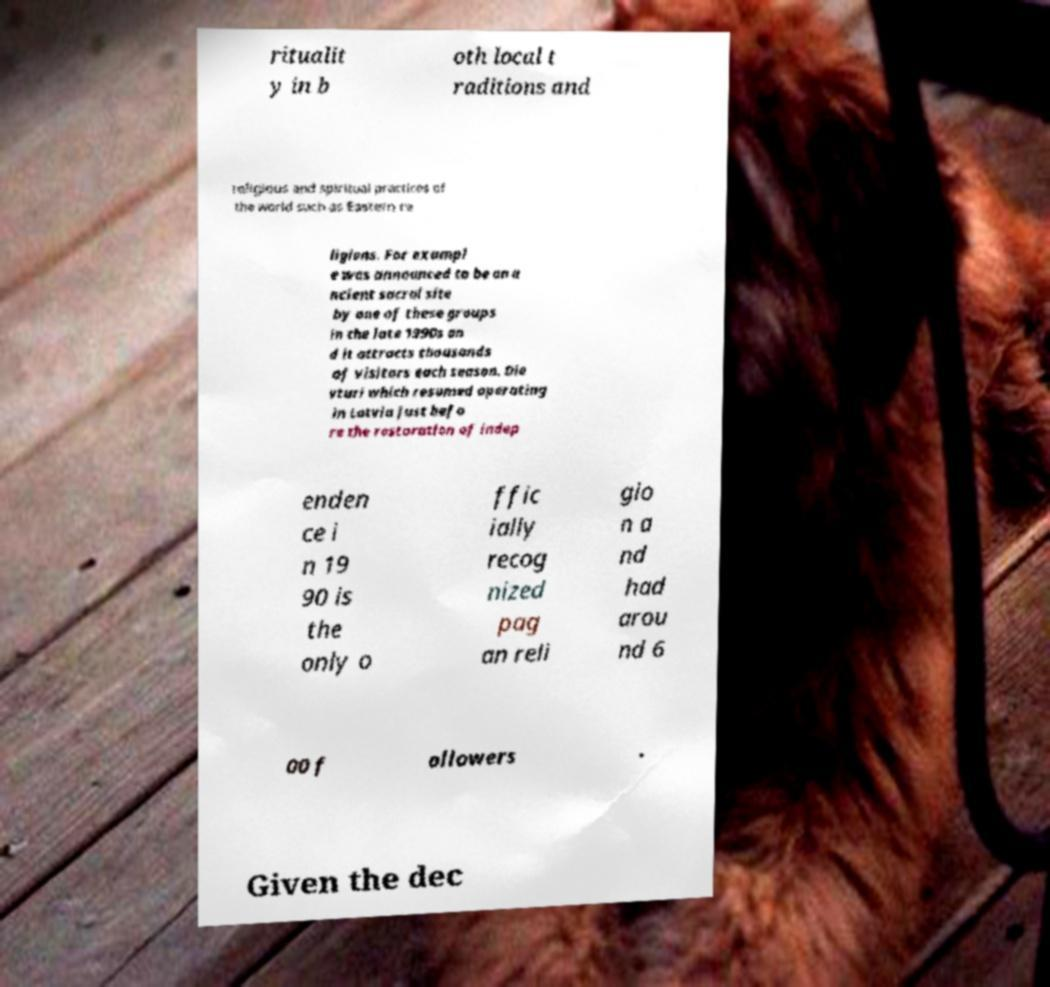There's text embedded in this image that I need extracted. Can you transcribe it verbatim? ritualit y in b oth local t raditions and religious and spiritual practices of the world such as Eastern re ligions. For exampl e was announced to be an a ncient sacral site by one of these groups in the late 1990s an d it attracts thousands of visitors each season. Die vturi which resumed operating in Latvia just befo re the restoration of indep enden ce i n 19 90 is the only o ffic ially recog nized pag an reli gio n a nd had arou nd 6 00 f ollowers . Given the dec 